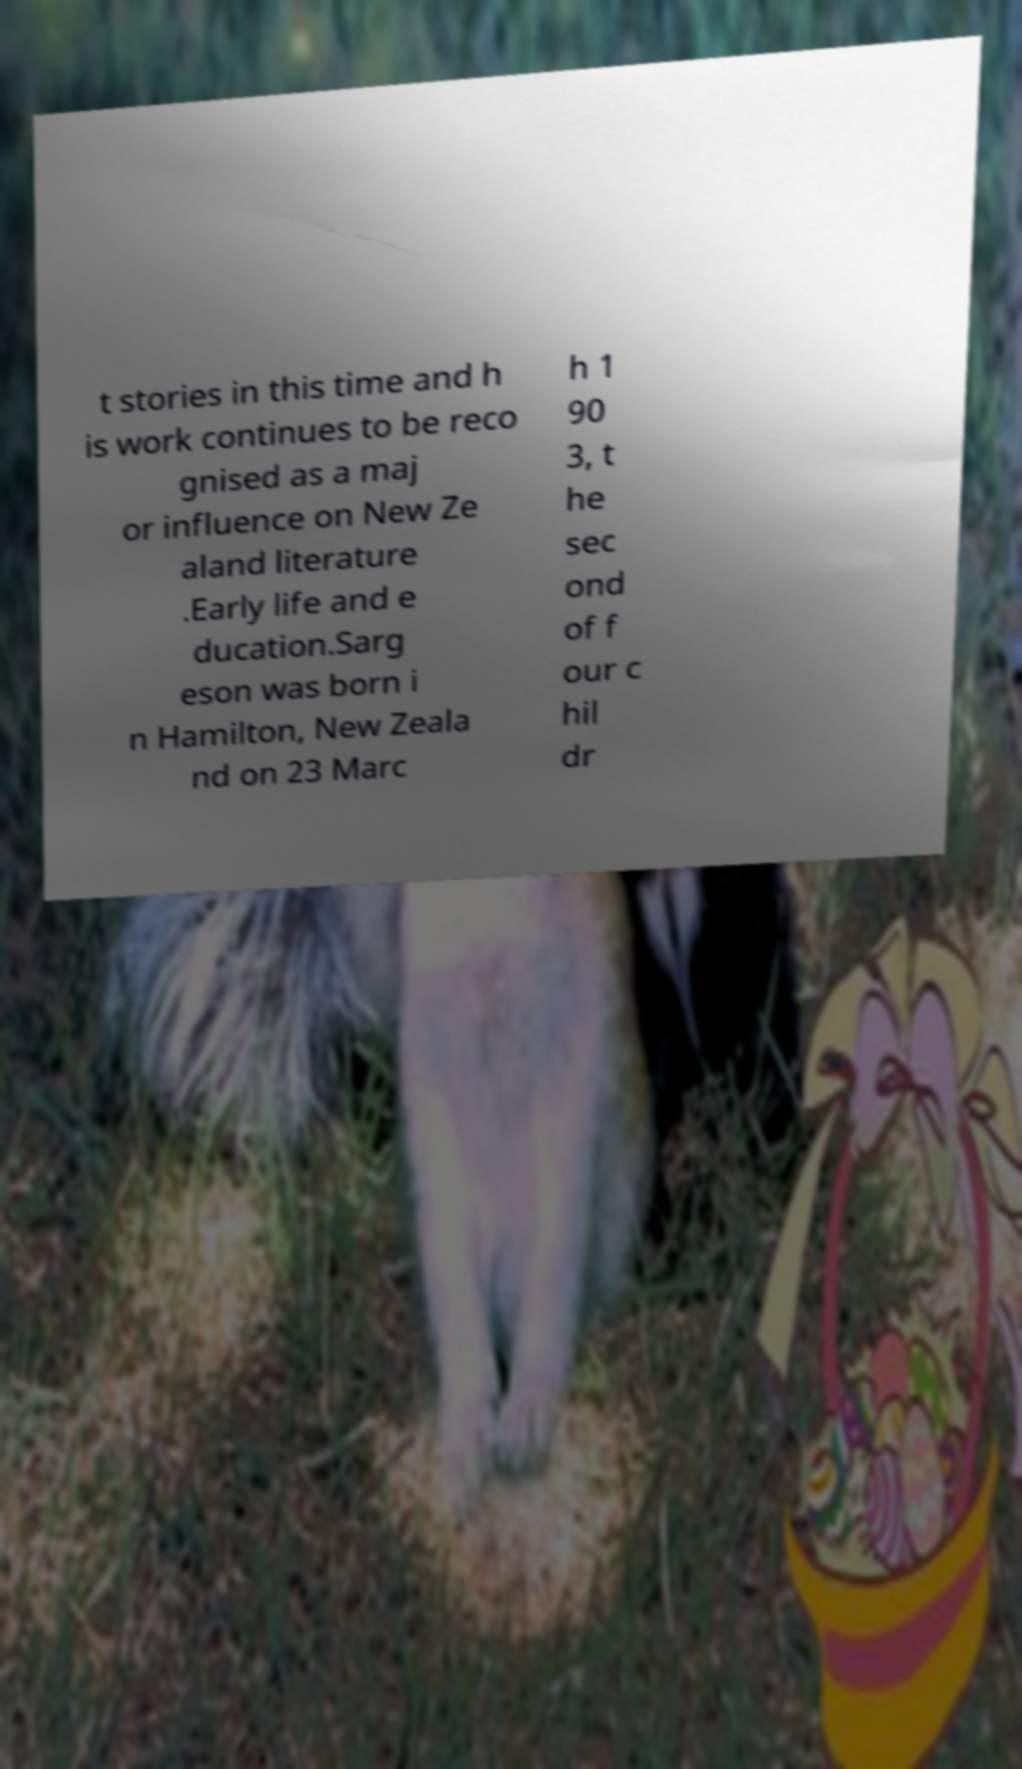I need the written content from this picture converted into text. Can you do that? t stories in this time and h is work continues to be reco gnised as a maj or influence on New Ze aland literature .Early life and e ducation.Sarg eson was born i n Hamilton, New Zeala nd on 23 Marc h 1 90 3, t he sec ond of f our c hil dr 